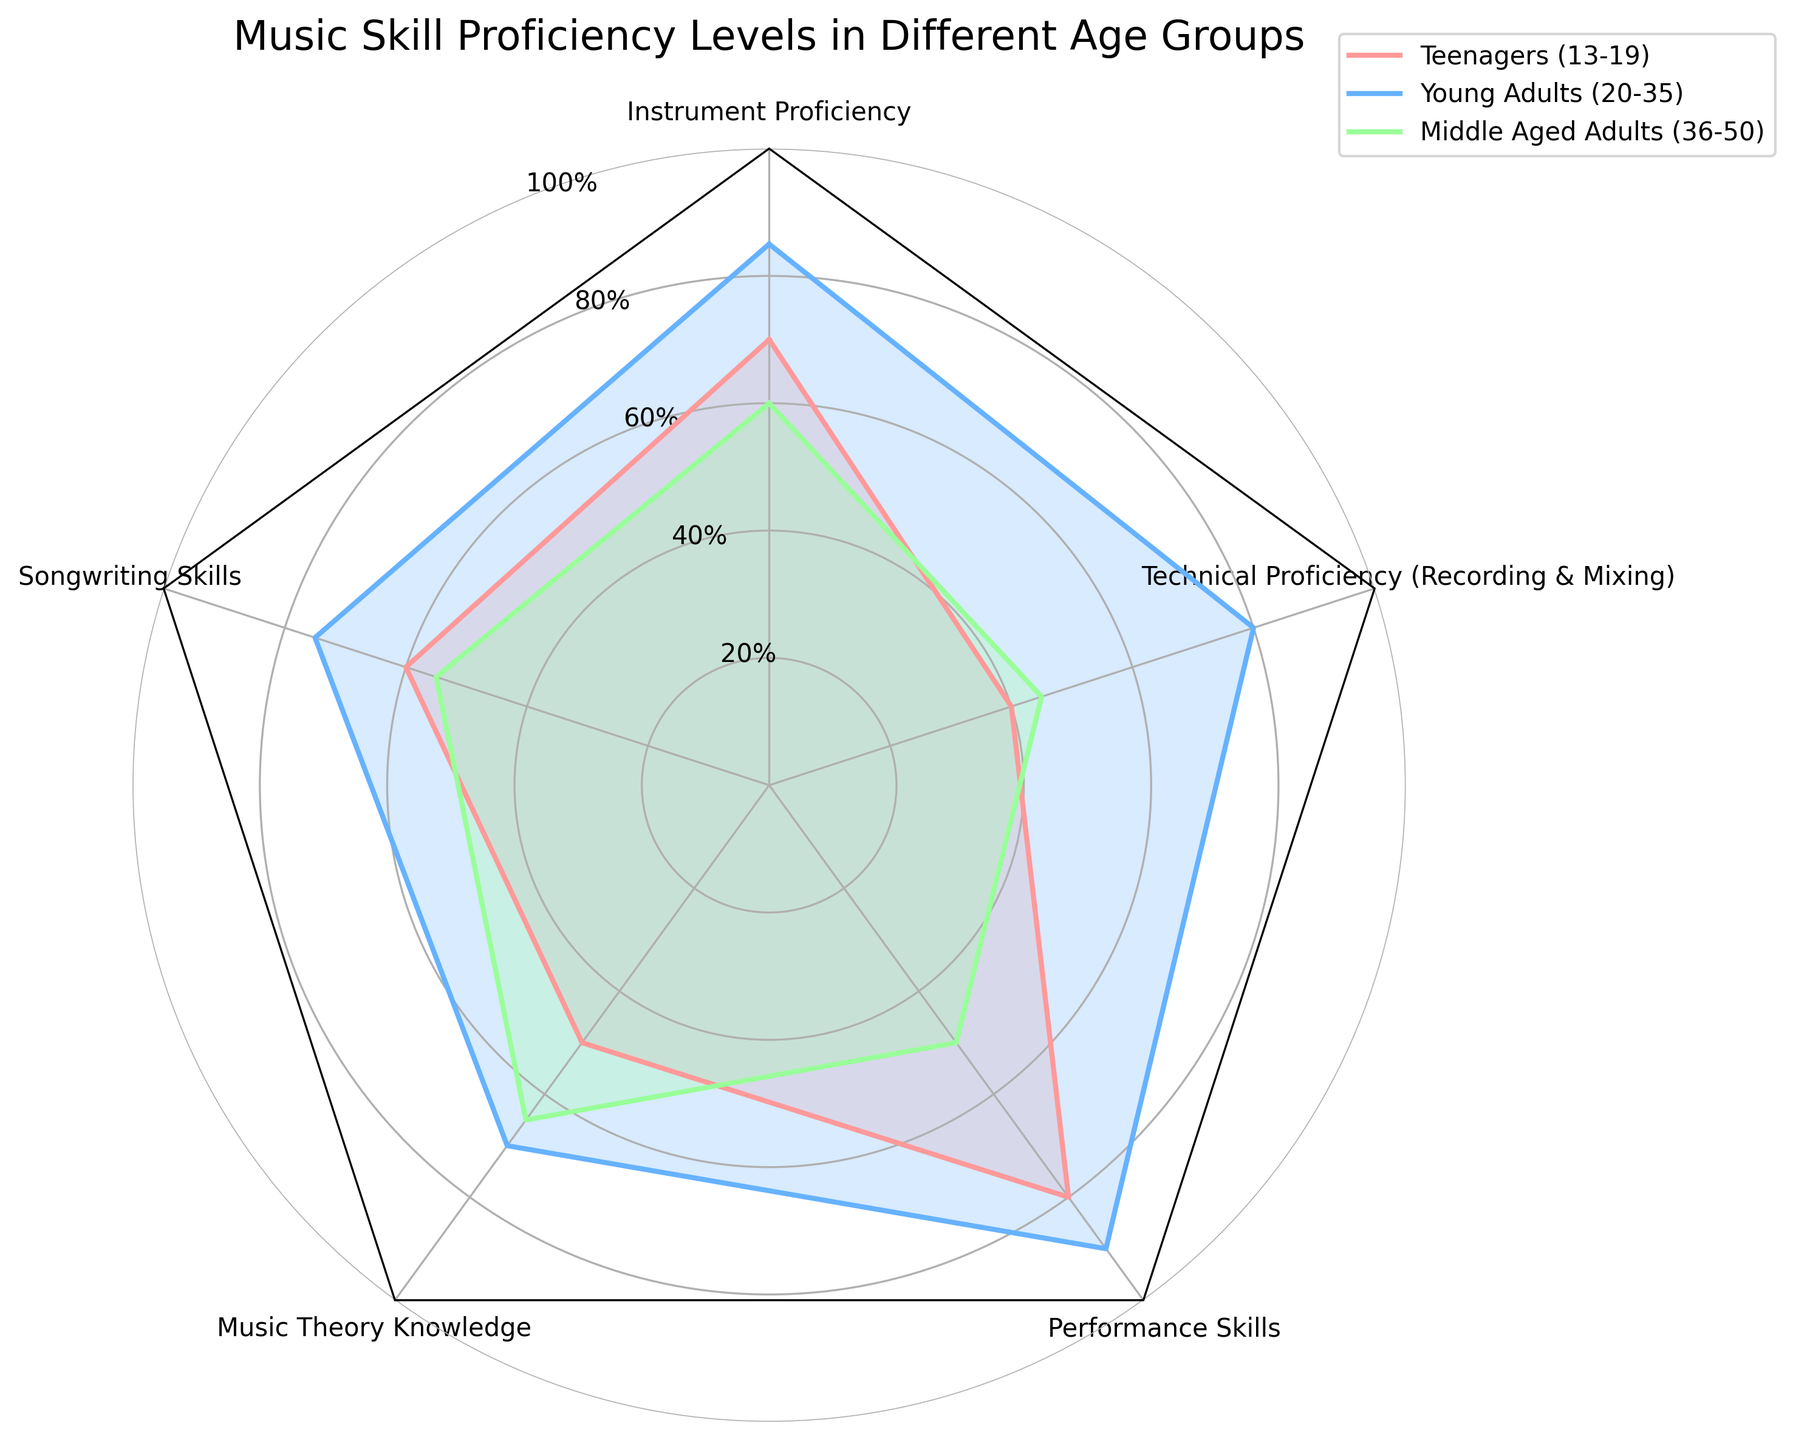What is the title of the radar chart? The title is usually located at the top center of the chart and describes the main topic of the visualization. Here, it reads "Music Skill Proficiency Levels in Different Age Groups".
Answer: Music Skill Proficiency Levels in Different Age Groups Which age group has the highest performance skills proficiency? Look at the values on the radar chart corresponding to Performance Skills for each age group. The highest point on this axis indicates the group.
Answer: Young Adults (90) Compare the Music Theory Knowledge levels between Teenagers and Middle Aged Adults. Which group has a higher level? Locate the Music Theory Knowledge values for both age groups on the radar chart and compare their heights.
Answer: Middle Aged Adults (65 vs. 50) What is the average proficiency for Instrument Proficiency across all age groups? Sum the values of Instrument Proficiency (70, 85, 60) and divide by the number of age groups (3): (70 + 85 + 60) / 3.
Answer: 71.67 Which music skill shows the greatest difference in proficiency levels between Teenagers and Young Adults? Calculate the absolute differences for each skill between Teenagers and Young Adults. The skill with the highest value is the answer. Instrument Proficiency: 85-70=15, Songwriting Skills: 75-60=15, Music Theory Knowledge: 70-50=20, Performance Skills: 90-80=10, Technical Proficiency: 80-40=40.  The largest difference is in Technical Proficiency.
Answer: Technical Proficiency (40) Is there any skill for which the proficiency level of Middle Aged Adults is higher than that of Teenagers and Young Adults? Compare the values of Middle Aged Adults with those of Teenagers and Young Adults for each skill. In this case, Middle Aged Adults do not have a higher value in any skill compared to both other groups.
Answer: No Which skill has the lowest proficiency level among Teenagers? Look for the smallest value in the Teenagers' proficiency levels from the radar chart. The lowest value is for Technical Proficiency.
Answer: Technical Proficiency (40) On average, which age group has the highest proficiency in all skills combined? Calculate the average proficiency for each age group: Teenagers: (70 + 60 + 50 + 80 + 40) / 5 = 60, Young Adults: (85 + 75 + 70 + 90 + 80) / 5 = 80, Middle Aged Adults: (60 + 55 + 65 + 50 + 45) / 5 = 55.
Answer: Young Adults (80) Are there any skills where Teenagers outperform Middle Aged Adults? Compare the proficiency levels of Teenagers and Middle Aged Adults for each skill and identify if Teenagers have a higher value in any skill. Identified skills are Instrument Proficiency, Songwriting Skills, and Performance Skills.
Answer: Yes, Instrument Proficiency, Songwriting Skills, Performance Skills 